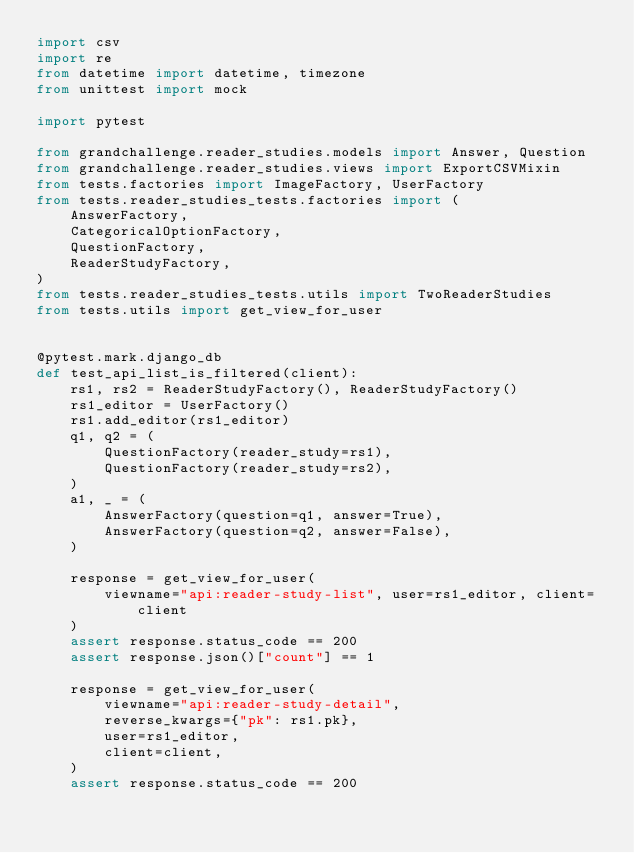Convert code to text. <code><loc_0><loc_0><loc_500><loc_500><_Python_>import csv
import re
from datetime import datetime, timezone
from unittest import mock

import pytest

from grandchallenge.reader_studies.models import Answer, Question
from grandchallenge.reader_studies.views import ExportCSVMixin
from tests.factories import ImageFactory, UserFactory
from tests.reader_studies_tests.factories import (
    AnswerFactory,
    CategoricalOptionFactory,
    QuestionFactory,
    ReaderStudyFactory,
)
from tests.reader_studies_tests.utils import TwoReaderStudies
from tests.utils import get_view_for_user


@pytest.mark.django_db
def test_api_list_is_filtered(client):
    rs1, rs2 = ReaderStudyFactory(), ReaderStudyFactory()
    rs1_editor = UserFactory()
    rs1.add_editor(rs1_editor)
    q1, q2 = (
        QuestionFactory(reader_study=rs1),
        QuestionFactory(reader_study=rs2),
    )
    a1, _ = (
        AnswerFactory(question=q1, answer=True),
        AnswerFactory(question=q2, answer=False),
    )

    response = get_view_for_user(
        viewname="api:reader-study-list", user=rs1_editor, client=client
    )
    assert response.status_code == 200
    assert response.json()["count"] == 1

    response = get_view_for_user(
        viewname="api:reader-study-detail",
        reverse_kwargs={"pk": rs1.pk},
        user=rs1_editor,
        client=client,
    )
    assert response.status_code == 200</code> 